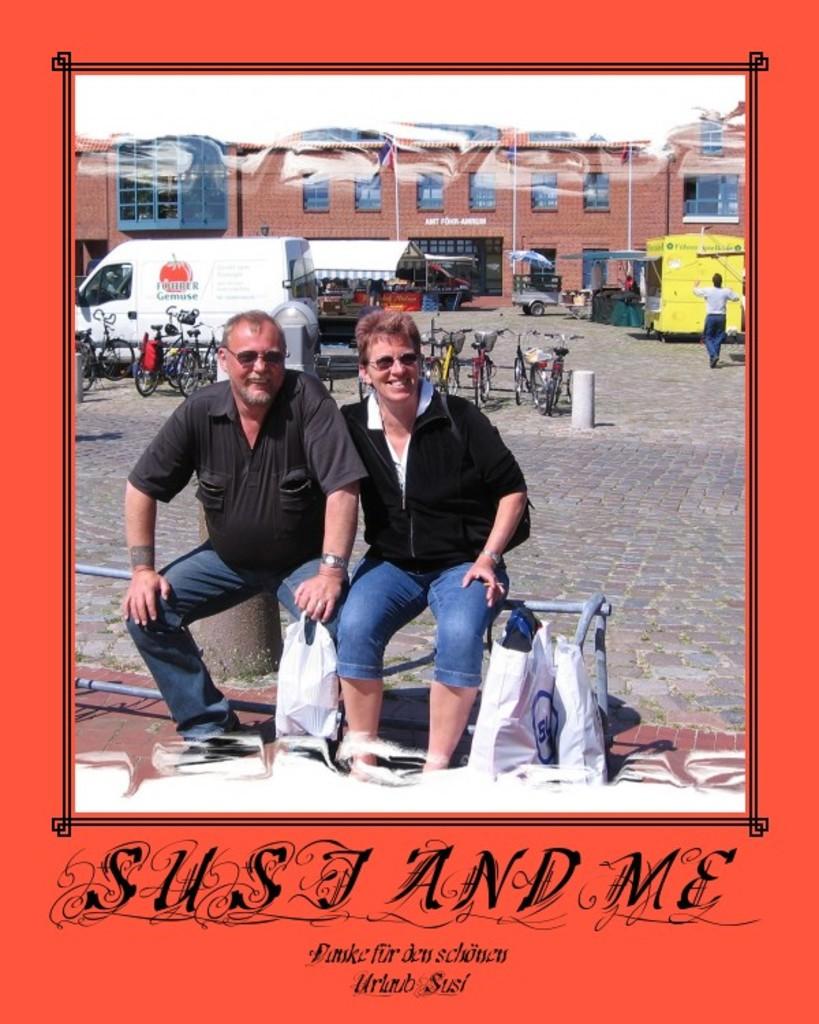What is the first name mentioned on the photograph?
Your answer should be compact. Susj. 